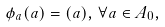Convert formula to latex. <formula><loc_0><loc_0><loc_500><loc_500>\phi _ { a } ( a ) = ( a ) , \, \forall a \in A _ { 0 } ,</formula> 